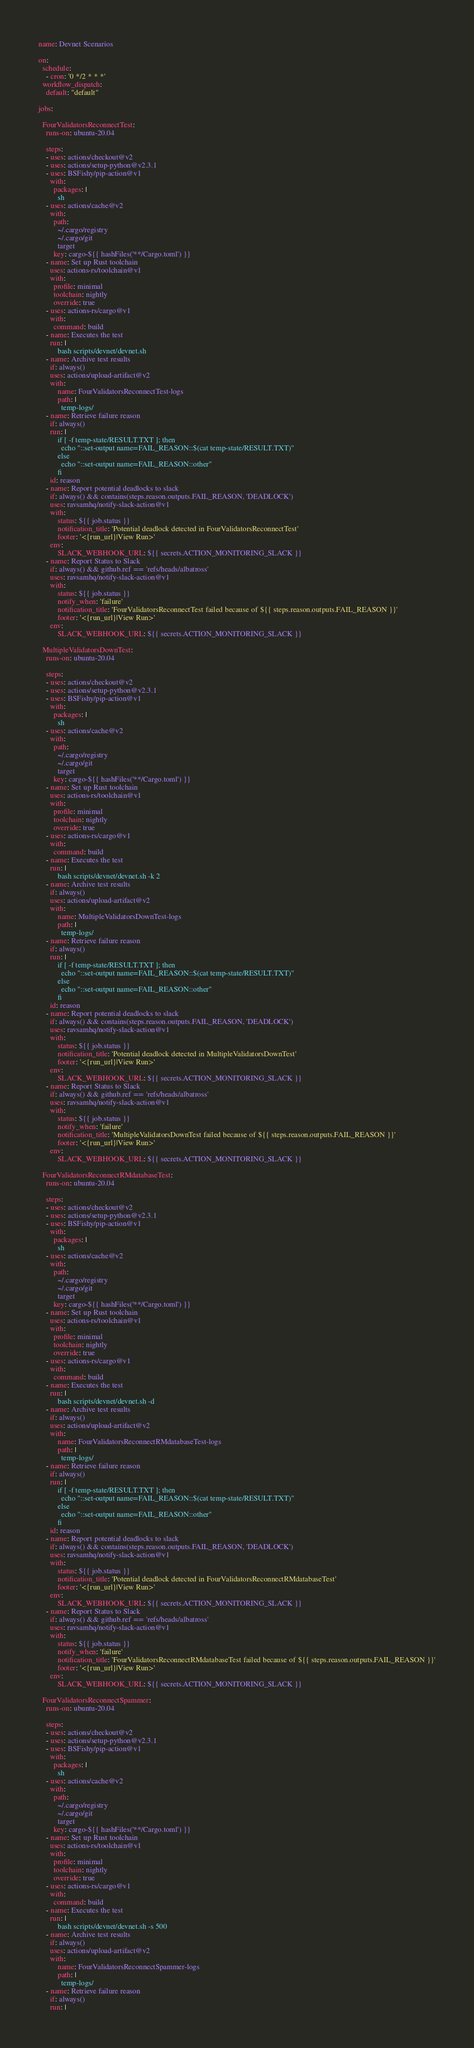<code> <loc_0><loc_0><loc_500><loc_500><_YAML_>name: Devnet Scenarios

on:
  schedule:
    - cron: '0 */2 * * *'
  workflow_dispatch:
    default: "default"

jobs:

  FourValidatorsReconnectTest:
    runs-on: ubuntu-20.04

    steps:
    - uses: actions/checkout@v2
    - uses: actions/setup-python@v2.3.1
    - uses: BSFishy/pip-action@v1
      with:
        packages: |
          sh
    - uses: actions/cache@v2
      with:
        path:
          ~/.cargo/registry
          ~/.cargo/git
          target
        key: cargo-${{ hashFiles('**/Cargo.toml') }}
    - name: Set up Rust toolchain
      uses: actions-rs/toolchain@v1
      with:
        profile: minimal
        toolchain: nightly
        override: true
    - uses: actions-rs/cargo@v1
      with:
        command: build
    - name: Executes the test
      run: |          
          bash scripts/devnet/devnet.sh
    - name: Archive test results
      if: always()
      uses: actions/upload-artifact@v2
      with:
          name: FourValidatorsReconnectTest-logs
          path: |
            temp-logs/
    - name: Retrieve failure reason
      if: always()
      run: |
          if [ -f temp-state/RESULT.TXT ]; then
            echo "::set-output name=FAIL_REASON::$(cat temp-state/RESULT.TXT)"
          else
            echo "::set-output name=FAIL_REASON::other"
          fi
      id: reason
    - name: Report potential deadlocks to slack
      if: always() && contains(steps.reason.outputs.FAIL_REASON, 'DEADLOCK')
      uses: ravsamhq/notify-slack-action@v1
      with:
          status: ${{ job.status }}
          notification_title: 'Potential deadlock detected in FourValidatorsReconnectTest'
          footer: '<{run_url}|View Run>'
      env:
          SLACK_WEBHOOK_URL: ${{ secrets.ACTION_MONITORING_SLACK }}
    - name: Report Status to Slack
      if: always() && github.ref == 'refs/heads/albatross'
      uses: ravsamhq/notify-slack-action@v1
      with:
          status: ${{ job.status }}
          notify_when: 'failure'
          notification_title: 'FourValidatorsReconnectTest failed because of ${{ steps.reason.outputs.FAIL_REASON }}'
          footer: '<{run_url}|View Run>'
      env:
          SLACK_WEBHOOK_URL: ${{ secrets.ACTION_MONITORING_SLACK }}
 
  MultipleValidatorsDownTest:
    runs-on: ubuntu-20.04

    steps:
    - uses: actions/checkout@v2
    - uses: actions/setup-python@v2.3.1
    - uses: BSFishy/pip-action@v1
      with:
        packages: |
          sh
    - uses: actions/cache@v2
      with:
        path:
          ~/.cargo/registry
          ~/.cargo/git
          target
        key: cargo-${{ hashFiles('**/Cargo.toml') }}
    - name: Set up Rust toolchain
      uses: actions-rs/toolchain@v1
      with:
        profile: minimal
        toolchain: nightly
        override: true
    - uses: actions-rs/cargo@v1
      with:
        command: build
    - name: Executes the test
      run: |
          bash scripts/devnet/devnet.sh -k 2
    - name: Archive test results
      if: always()
      uses: actions/upload-artifact@v2
      with:
          name: MultipleValidatorsDownTest-logs
          path: |
            temp-logs/
    - name: Retrieve failure reason
      if: always()
      run: |
          if [ -f temp-state/RESULT.TXT ]; then
            echo "::set-output name=FAIL_REASON::$(cat temp-state/RESULT.TXT)"
          else
            echo "::set-output name=FAIL_REASON::other"
          fi
      id: reason
    - name: Report potential deadlocks to slack
      if: always() && contains(steps.reason.outputs.FAIL_REASON, 'DEADLOCK')
      uses: ravsamhq/notify-slack-action@v1
      with:
          status: ${{ job.status }}
          notification_title: 'Potential deadlock detected in MultipleValidatorsDownTest'
          footer: '<{run_url}|View Run>'
      env:
          SLACK_WEBHOOK_URL: ${{ secrets.ACTION_MONITORING_SLACK }}
    - name: Report Status to Slack
      if: always() && github.ref == 'refs/heads/albatross'
      uses: ravsamhq/notify-slack-action@v1
      with:
          status: ${{ job.status }}
          notify_when: 'failure'
          notification_title: 'MultipleValidatorsDownTest failed because of ${{ steps.reason.outputs.FAIL_REASON }}'
          footer: '<{run_url}|View Run>'
      env:
          SLACK_WEBHOOK_URL: ${{ secrets.ACTION_MONITORING_SLACK }}

  FourValidatorsReconnectRMdatabaseTest:
    runs-on: ubuntu-20.04

    steps:
    - uses: actions/checkout@v2
    - uses: actions/setup-python@v2.3.1
    - uses: BSFishy/pip-action@v1
      with:
        packages: |
          sh
    - uses: actions/cache@v2
      with:
        path:
          ~/.cargo/registry
          ~/.cargo/git
          target
        key: cargo-${{ hashFiles('**/Cargo.toml') }}
    - name: Set up Rust toolchain
      uses: actions-rs/toolchain@v1
      with:
        profile: minimal
        toolchain: nightly
        override: true
    - uses: actions-rs/cargo@v1
      with:
        command: build
    - name: Executes the test
      run: |          
          bash scripts/devnet/devnet.sh -d
    - name: Archive test results
      if: always()
      uses: actions/upload-artifact@v2
      with:
          name: FourValidatorsReconnectRMdatabaseTest-logs
          path: |
            temp-logs/
    - name: Retrieve failure reason
      if: always()
      run: |
          if [ -f temp-state/RESULT.TXT ]; then
            echo "::set-output name=FAIL_REASON::$(cat temp-state/RESULT.TXT)"
          else
            echo "::set-output name=FAIL_REASON::other"
          fi
      id: reason
    - name: Report potential deadlocks to slack
      if: always() && contains(steps.reason.outputs.FAIL_REASON, 'DEADLOCK')
      uses: ravsamhq/notify-slack-action@v1
      with:
          status: ${{ job.status }}
          notification_title: 'Potential deadlock detected in FourValidatorsReconnectRMdatabaseTest'
          footer: '<{run_url}|View Run>'
      env:
          SLACK_WEBHOOK_URL: ${{ secrets.ACTION_MONITORING_SLACK }}
    - name: Report Status to Slack
      if: always() && github.ref == 'refs/heads/albatross'
      uses: ravsamhq/notify-slack-action@v1
      with:
          status: ${{ job.status }}
          notify_when: 'failure'
          notification_title: 'FourValidatorsReconnectRMdatabaseTest failed because of ${{ steps.reason.outputs.FAIL_REASON }}'
          footer: '<{run_url}|View Run>'
      env:
          SLACK_WEBHOOK_URL: ${{ secrets.ACTION_MONITORING_SLACK }}

  FourValidatorsReconnectSpammer:
    runs-on: ubuntu-20.04

    steps:
    - uses: actions/checkout@v2
    - uses: actions/setup-python@v2.3.1
    - uses: BSFishy/pip-action@v1
      with:
        packages: |
          sh
    - uses: actions/cache@v2
      with:
        path:
          ~/.cargo/registry
          ~/.cargo/git
          target
        key: cargo-${{ hashFiles('**/Cargo.toml') }}
    - name: Set up Rust toolchain
      uses: actions-rs/toolchain@v1
      with:
        profile: minimal
        toolchain: nightly
        override: true
    - uses: actions-rs/cargo@v1
      with:
        command: build
    - name: Executes the test
      run: |
          bash scripts/devnet/devnet.sh -s 500
    - name: Archive test results
      if: always()
      uses: actions/upload-artifact@v2
      with:
          name: FourValidatorsReconnectSpammer-logs
          path: |
            temp-logs/
    - name: Retrieve failure reason
      if: always()
      run: |</code> 